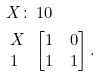<formula> <loc_0><loc_0><loc_500><loc_500>X \colon & \, 1 0 \\ \begin{array} { l } X \\ 1 \end{array} & \begin{bmatrix} 1 & 0 \\ 1 & 1 \end{bmatrix} .</formula> 